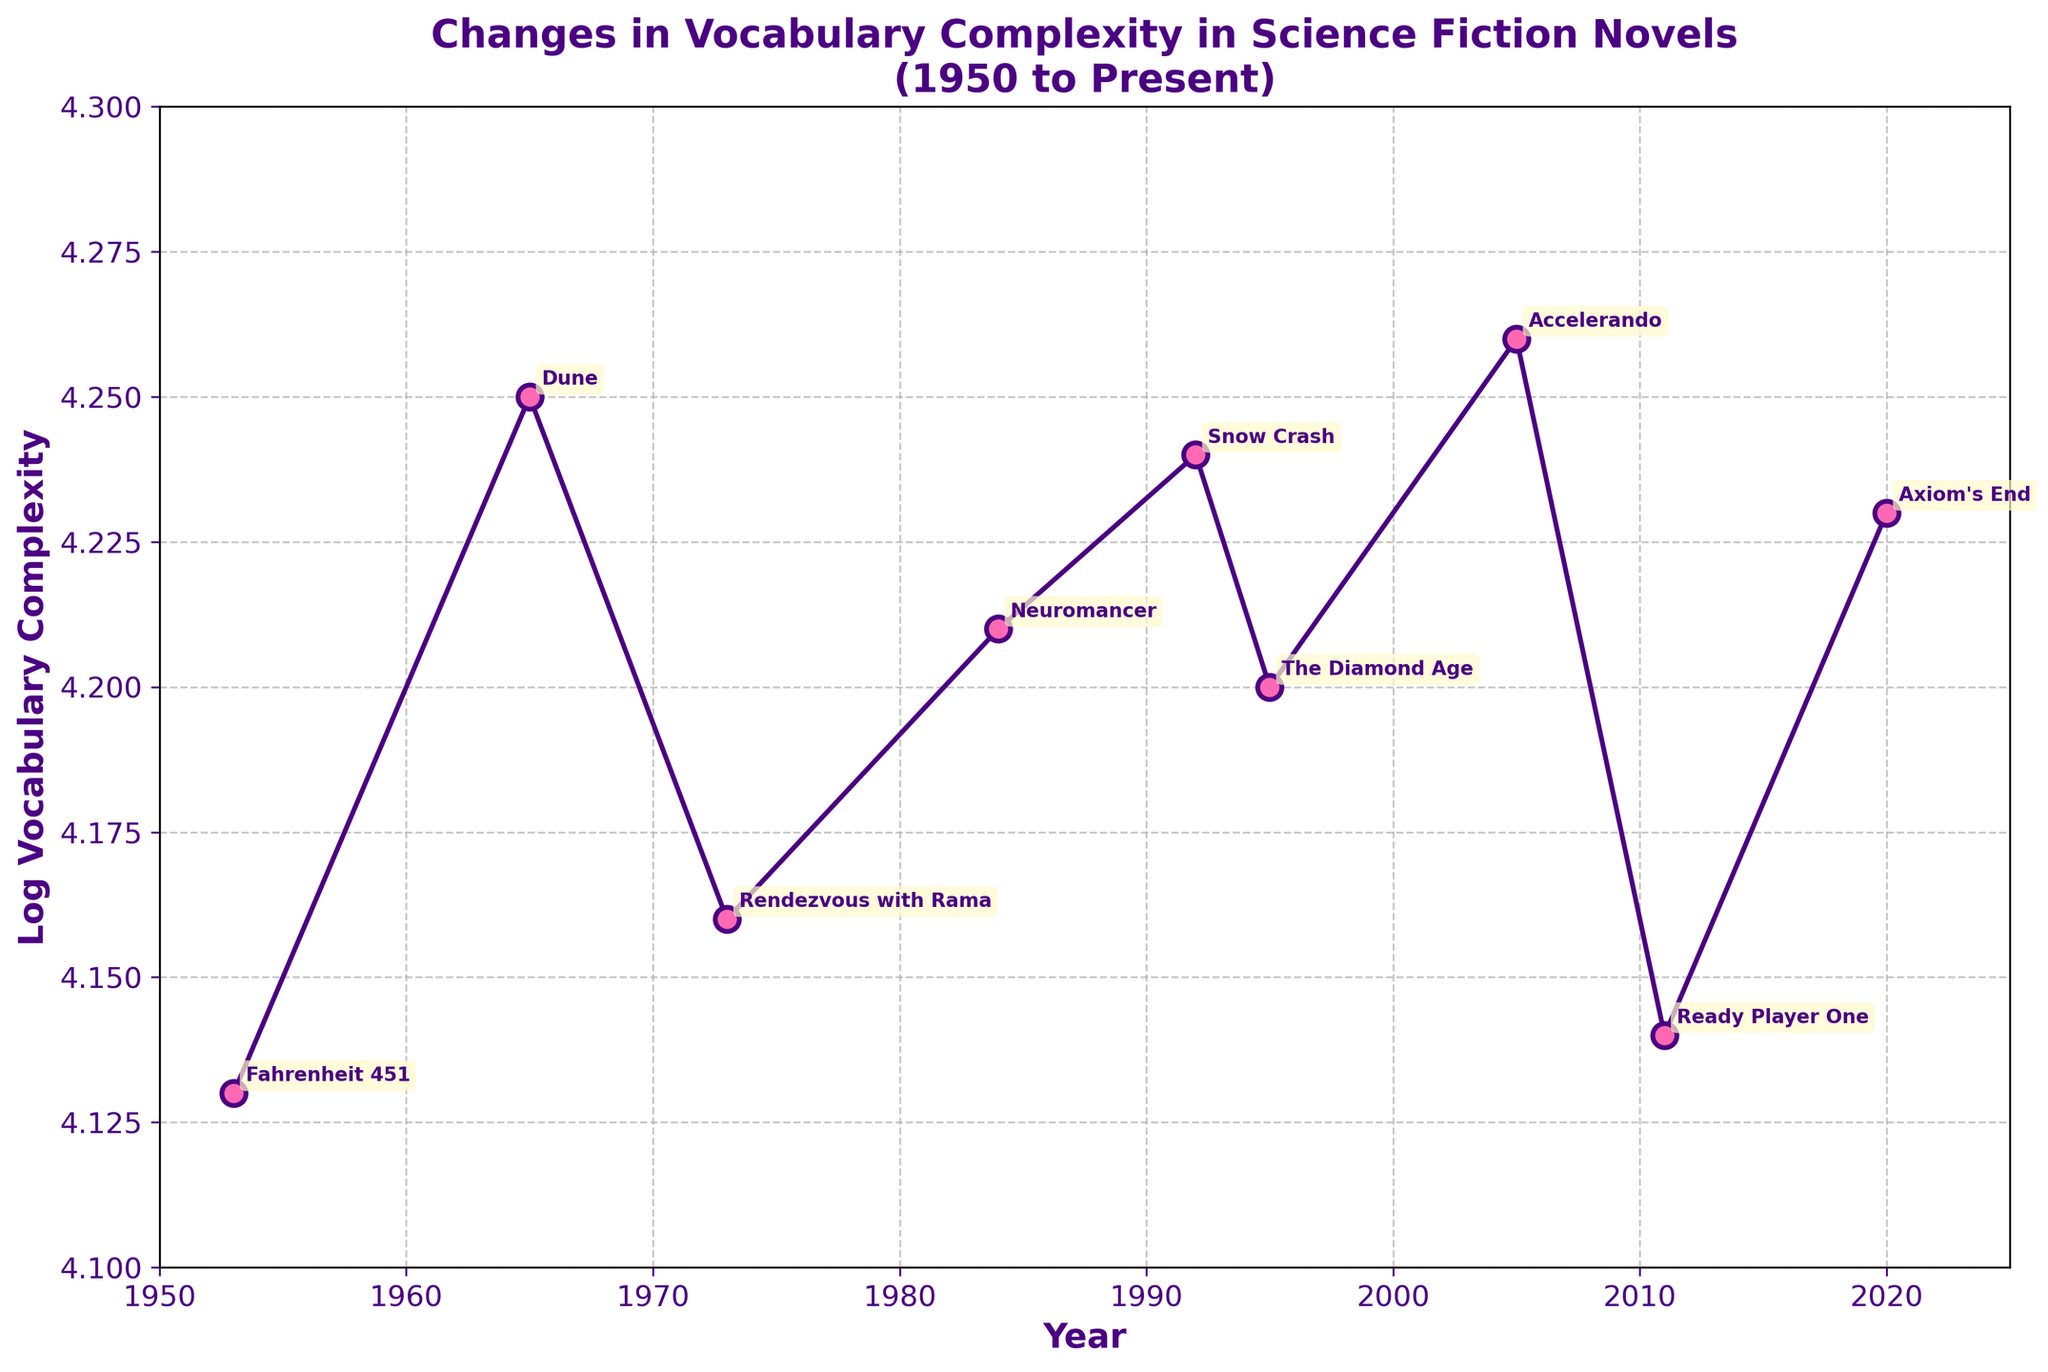What is the title of the plot? The title of the plot is displayed at the top of the figure. It reads "Changes in Vocabulary Complexity in Science Fiction Novels (1950 to Present)."
Answer: Changes in Vocabulary Complexity in Science Fiction Novels (1950 to Present) What is the range of the y-axis? The y-axis represents Log Vocabulary Complexity, ranging from about 4.1 to 4.3. This is observed by looking at the minimum and maximum values marked on the axis.
Answer: 4.1 to 4.3 How many novels are plotted on the figure? Each data point on the figure corresponds to a novel, and we can count the number of points along the line. There are 9 data points.
Answer: 9 Which novel has the highest vocabulary complexity? To identify this, look for the highest y-value on the plot. The highest point corresponds to the novel "Accelerando" by Charles Stross in 2005.
Answer: Accelerando What is the average Log Vocabulary Complexity of the novels from 2000 onwards? To find this, examine the log vocabulary complexity values for the novels from 2000 onwards: Accelerando (4.26), Ready Player One (4.14), and Axiom's End (4.23). Calculate the average: (4.26 + 4.14 + 4.23) / 3 ≈ 4.21.
Answer: ≈ 4.21 Which author has more novels plotted, Neal Stephenson or Frank Herbert? Neal Stephenson has two novels, while Frank Herbert has only one. This is directly observed from the annotations in the plot indicating the authors.
Answer: Neal Stephenson Did vocabulary complexity increase or decrease from 1953 to 2020? To evaluate this, compare the log vocabulary complexity values for 1953 ("Fahrenheit 451" - 4.13) and 2020 ("Axiom's End" - 4.23). The complexity increased.
Answer: Increased What is the difference in Log Vocabulary Complexity between "Dune" (1965) and "Snow Crash" (1992)? Determine the values from the plot: Dune (4.25) and Snow Crash (4.24). The difference is 4.25 - 4.24 = 0.01.
Answer: 0.01 Which novel has the lowest vocabulary complexity, and in which year was it published? The lowest point on the plot indicates the novel with the lowest complexity: "Fahrenheit 451" in 1953.
Answer: Fahrenheit 451, 1953 